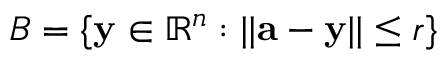Convert formula to latex. <formula><loc_0><loc_0><loc_500><loc_500>B = \{ y \in \mathbb { R } ^ { n } \colon | | a - y | | \leq r \}</formula> 